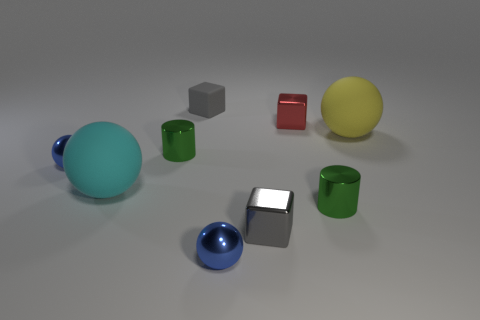There is a matte sphere that is in front of the big object that is right of the small red metal cube; what size is it?
Your response must be concise. Large. Does the large cyan object have the same material as the large thing to the right of the big cyan rubber thing?
Keep it short and to the point. Yes. Is the number of small blue metal spheres in front of the red metallic thing less than the number of things that are to the left of the rubber block?
Offer a very short reply. Yes. There is a ball that is the same material as the big yellow object; what is its color?
Keep it short and to the point. Cyan. Are there any big cyan rubber spheres that are right of the small metallic cube behind the small gray metallic thing?
Offer a terse response. No. The matte thing that is the same size as the red block is what color?
Give a very brief answer. Gray. What number of things are either big yellow spheres or gray objects?
Offer a terse response. 3. What is the size of the matte sphere that is left of the blue sphere in front of the small green metal thing that is on the right side of the small gray matte cube?
Keep it short and to the point. Large. How many small things are the same color as the tiny matte cube?
Your answer should be very brief. 1. What number of cylinders have the same material as the yellow ball?
Give a very brief answer. 0. 